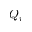Convert formula to latex. <formula><loc_0><loc_0><loc_500><loc_500>Q _ { i }</formula> 